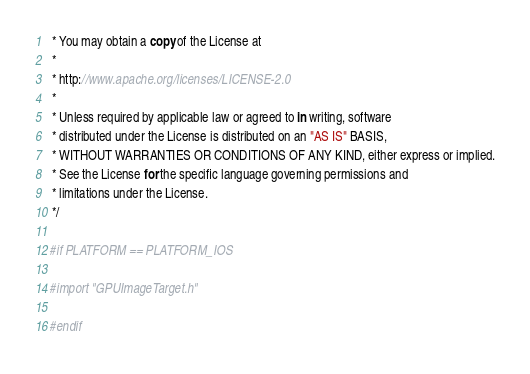<code> <loc_0><loc_0><loc_500><loc_500><_ObjectiveC_> * You may obtain a copy of the License at
 *
 * http://www.apache.org/licenses/LICENSE-2.0
 *
 * Unless required by applicable law or agreed to in writing, software
 * distributed under the License is distributed on an "AS IS" BASIS,
 * WITHOUT WARRANTIES OR CONDITIONS OF ANY KIND, either express or implied.
 * See the License for the specific language governing permissions and
 * limitations under the License.
 */

#if PLATFORM == PLATFORM_IOS

#import "GPUImageTarget.h"

#endif
</code> 